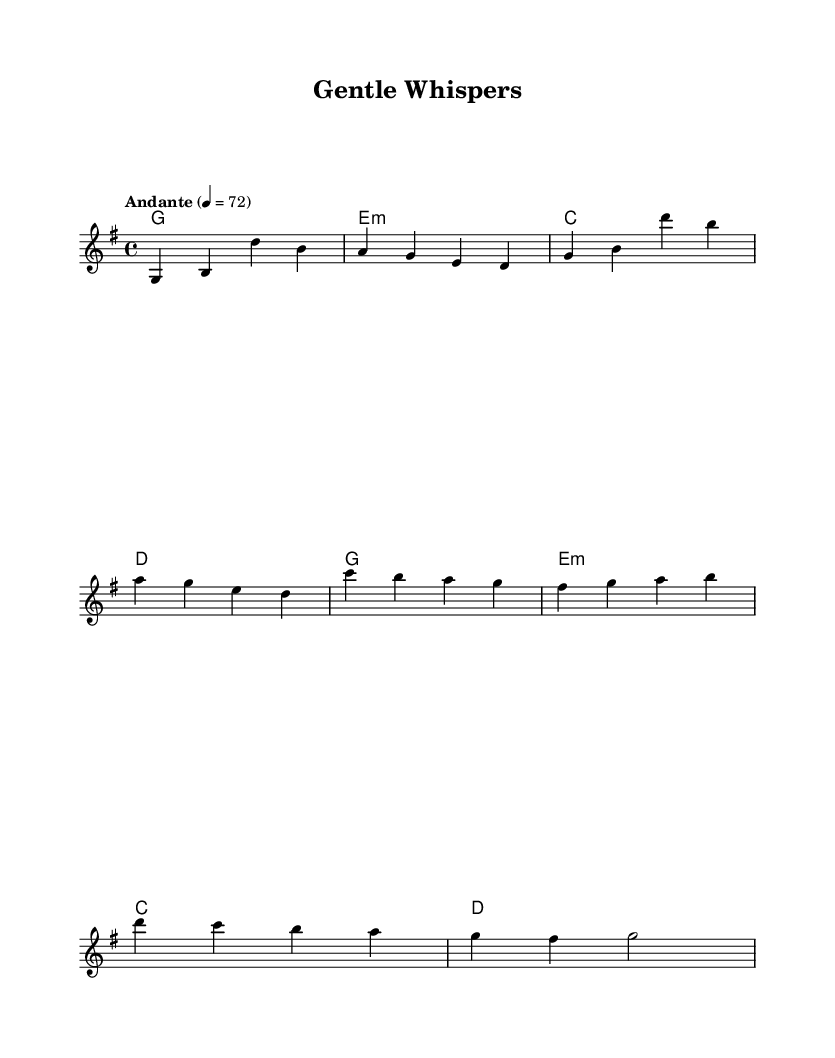What is the key signature of this music? The key signature shown is G major, which has one sharp (F#). This can be identified at the beginning of the sheet music where the clef and key signature are mentioned.
Answer: G major What is the time signature of the piece? The time signature is indicated at the start of the score and is 4/4. This means there are four beats per measure, and the quarter note gets one beat.
Answer: 4/4 What is the tempo marking of this song? The tempo marking "Andante" is written in the score, which indicates a moderate pace. The metronome indication of 4 = 72 is also specified, suggesting the beats per minute.
Answer: Andante How many measures are in the melody? By counting the individual measures in the melody part displayed on the sheet music, I can identify there are eight measures total.
Answer: Eight measures What chord is played in the first measure? The first measure indicates a G major chord, which is represented at the start of the harmonies section. The chord is shown in the chord names format.
Answer: G major What is the last note of the melody? The last note of the melody in the provided sheet music is a G note, which is indicated at the end of the melody staff.
Answer: G Which chord follows the E minor chord in the harmonies? Looking at the chord progression in the harmonies section, it is clear that a C major chord follows the E minor chord right after the first bar.
Answer: C major 